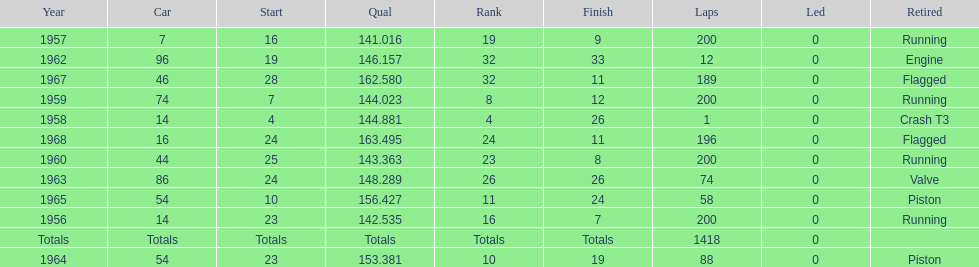How many times was bob veith ranked higher than 10 at an indy 500? 2. 